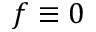<formula> <loc_0><loc_0><loc_500><loc_500>f \equiv 0</formula> 